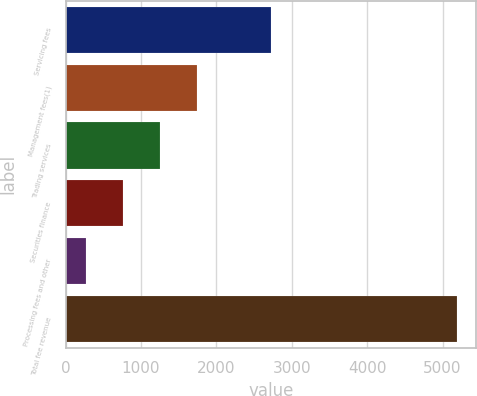<chart> <loc_0><loc_0><loc_500><loc_500><bar_chart><fcel>Servicing fees<fcel>Management fees(1)<fcel>Trading services<fcel>Securities finance<fcel>Processing fees and other<fcel>Total fee revenue<nl><fcel>2723<fcel>1746.2<fcel>1254.8<fcel>763.4<fcel>272<fcel>5186<nl></chart> 